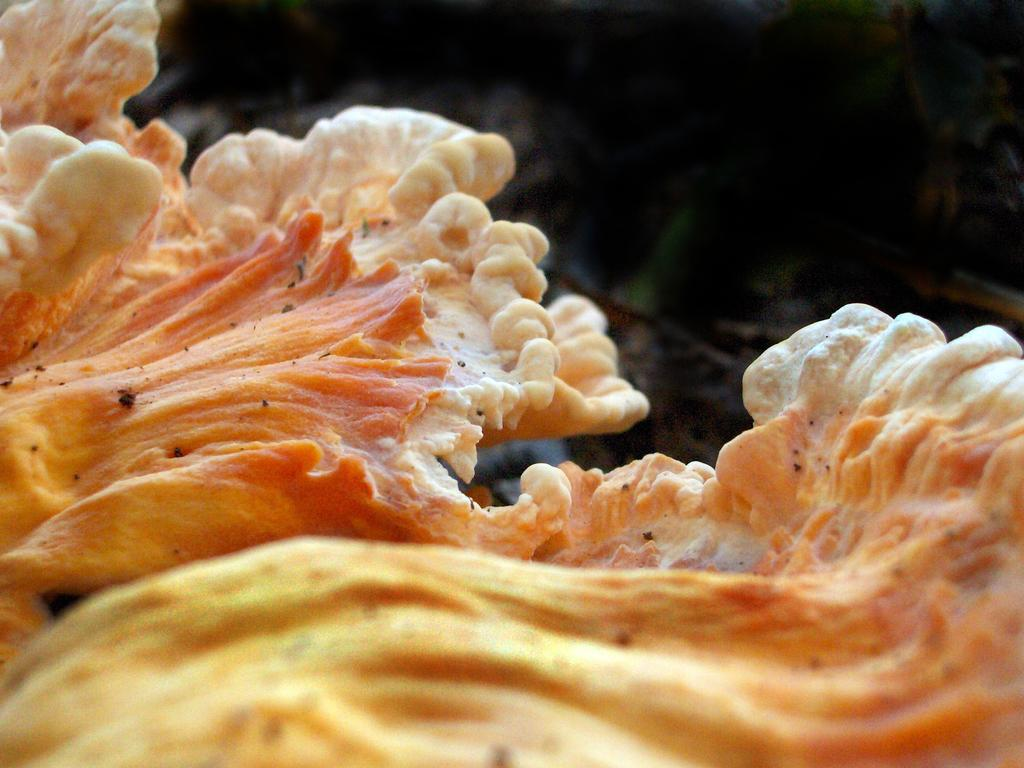What can be seen in the image? There is an object in the image. Can you describe the background of the image? The background of the image is blurred. How many spiders are crawling on the wing of the pear in the image? There is no pear, wing, or spiders present in the image. 